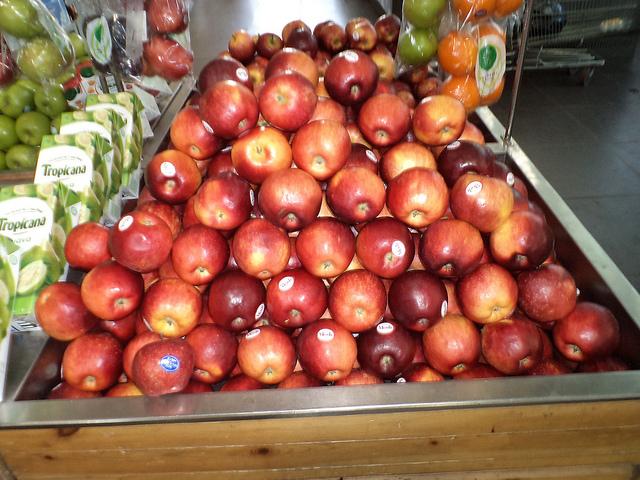Is there more than one type of fruit shown?
Write a very short answer. Yes. What kind of apples are these?
Concise answer only. Red. Where is this?
Concise answer only. Market. Are all the apples the same color?
Keep it brief. Yes. 